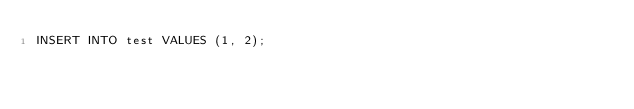<code> <loc_0><loc_0><loc_500><loc_500><_SQL_>INSERT INTO test VALUES (1, 2);
</code> 